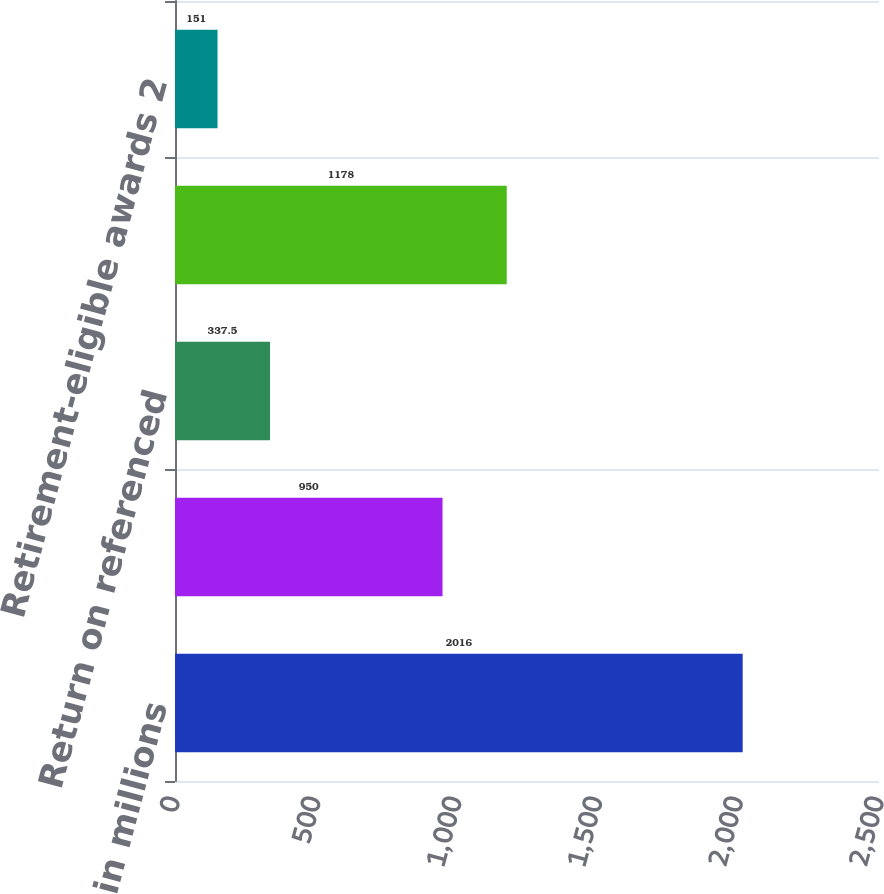<chart> <loc_0><loc_0><loc_500><loc_500><bar_chart><fcel>in millions<fcel>Deferred cash-based awards<fcel>Return on referenced<fcel>Total 1<fcel>Retirement-eligible awards 2<nl><fcel>2016<fcel>950<fcel>337.5<fcel>1178<fcel>151<nl></chart> 